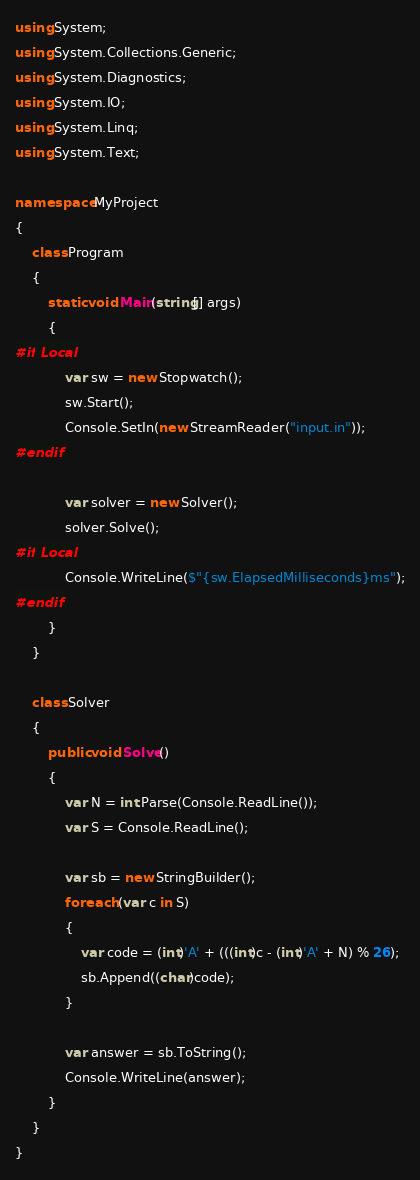<code> <loc_0><loc_0><loc_500><loc_500><_C#_>using System;
using System.Collections.Generic;
using System.Diagnostics;
using System.IO;
using System.Linq;
using System.Text;

namespace MyProject
{
    class Program
    {
        static void Main(string[] args)
        {
#if Local
            var sw = new Stopwatch();
            sw.Start();
            Console.SetIn(new StreamReader("input.in"));
#endif

            var solver = new Solver();
            solver.Solve();
#if Local
            Console.WriteLine($"{sw.ElapsedMilliseconds}ms");
#endif
        }
    }

    class Solver
    {
        public void Solve()
        {
            var N = int.Parse(Console.ReadLine());
            var S = Console.ReadLine();

            var sb = new StringBuilder();
            foreach (var c in S)
            {
                var code = (int)'A' + (((int)c - (int)'A' + N) % 26);
                sb.Append((char)code);
            }

            var answer = sb.ToString();
            Console.WriteLine(answer);
        }
    }
}
</code> 